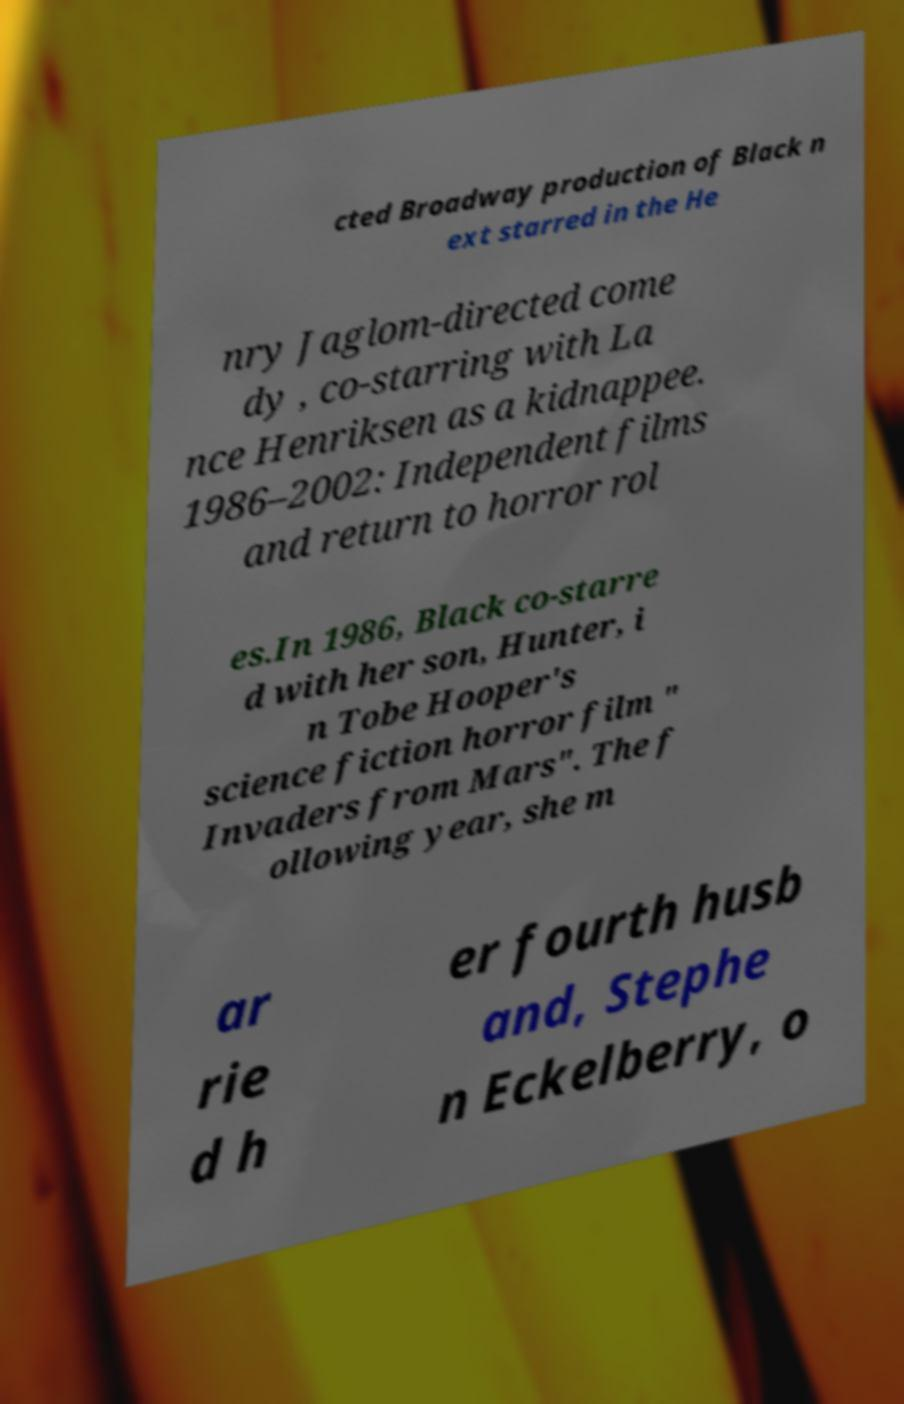Could you extract and type out the text from this image? cted Broadway production of Black n ext starred in the He nry Jaglom-directed come dy , co-starring with La nce Henriksen as a kidnappee. 1986–2002: Independent films and return to horror rol es.In 1986, Black co-starre d with her son, Hunter, i n Tobe Hooper's science fiction horror film " Invaders from Mars". The f ollowing year, she m ar rie d h er fourth husb and, Stephe n Eckelberry, o 